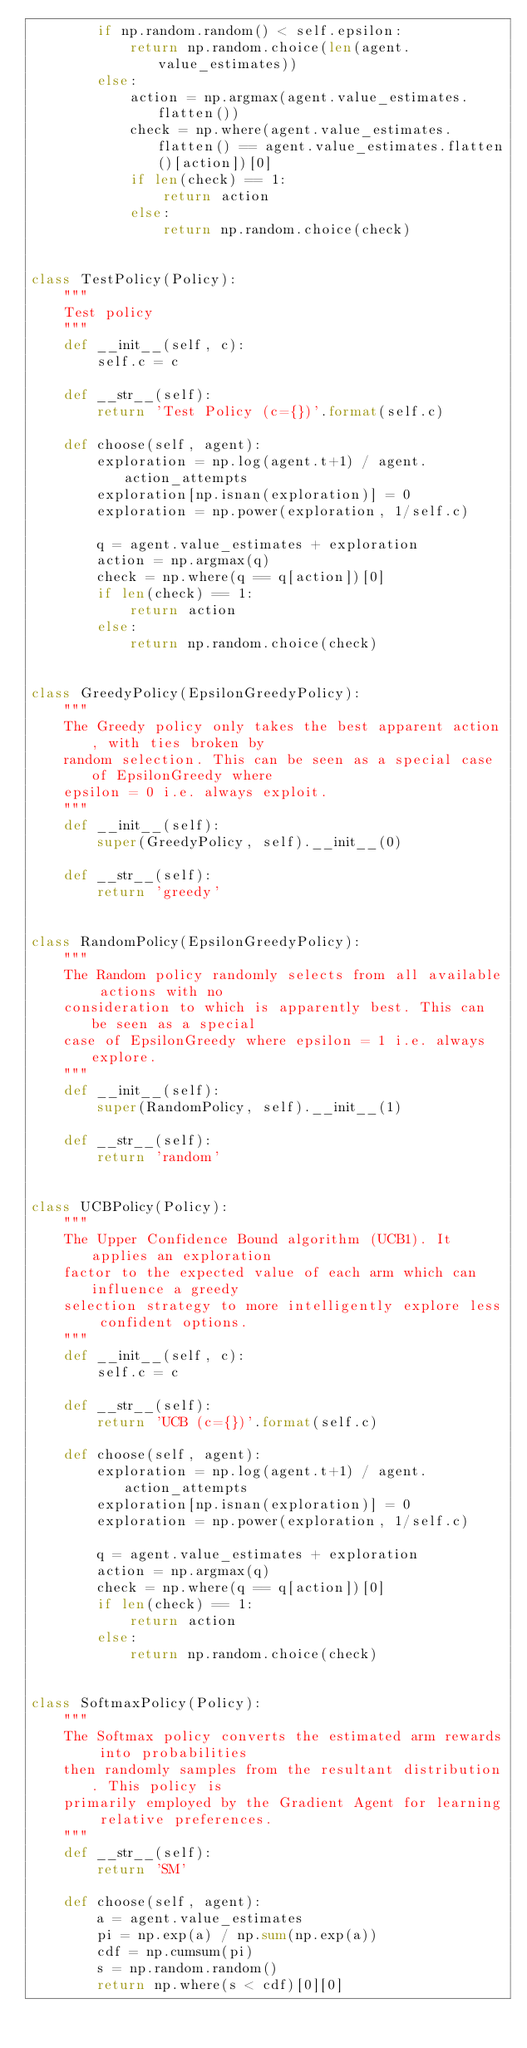<code> <loc_0><loc_0><loc_500><loc_500><_Python_>        if np.random.random() < self.epsilon:
            return np.random.choice(len(agent.value_estimates))
        else:
            action = np.argmax(agent.value_estimates.flatten())
            check = np.where(agent.value_estimates.flatten() == agent.value_estimates.flatten()[action])[0]
            if len(check) == 1:
                return action
            else:
                return np.random.choice(check)


class TestPolicy(Policy):
    """
    Test policy
    """
    def __init__(self, c):
        self.c = c

    def __str__(self):
        return 'Test Policy (c={})'.format(self.c)

    def choose(self, agent):
        exploration = np.log(agent.t+1) / agent.action_attempts
        exploration[np.isnan(exploration)] = 0
        exploration = np.power(exploration, 1/self.c)

        q = agent.value_estimates + exploration
        action = np.argmax(q)
        check = np.where(q == q[action])[0]
        if len(check) == 1:
            return action
        else:
            return np.random.choice(check)


class GreedyPolicy(EpsilonGreedyPolicy):
    """
    The Greedy policy only takes the best apparent action, with ties broken by
    random selection. This can be seen as a special case of EpsilonGreedy where
    epsilon = 0 i.e. always exploit.
    """
    def __init__(self):
        super(GreedyPolicy, self).__init__(0)

    def __str__(self):
        return 'greedy'


class RandomPolicy(EpsilonGreedyPolicy):
    """
    The Random policy randomly selects from all available actions with no
    consideration to which is apparently best. This can be seen as a special
    case of EpsilonGreedy where epsilon = 1 i.e. always explore.
    """
    def __init__(self):
        super(RandomPolicy, self).__init__(1)

    def __str__(self):
        return 'random'


class UCBPolicy(Policy):
    """
    The Upper Confidence Bound algorithm (UCB1). It applies an exploration
    factor to the expected value of each arm which can influence a greedy
    selection strategy to more intelligently explore less confident options.
    """
    def __init__(self, c):
        self.c = c

    def __str__(self):
        return 'UCB (c={})'.format(self.c)

    def choose(self, agent):
        exploration = np.log(agent.t+1) / agent.action_attempts
        exploration[np.isnan(exploration)] = 0
        exploration = np.power(exploration, 1/self.c)

        q = agent.value_estimates + exploration
        action = np.argmax(q)
        check = np.where(q == q[action])[0]
        if len(check) == 1:
            return action
        else:
            return np.random.choice(check)


class SoftmaxPolicy(Policy):
    """
    The Softmax policy converts the estimated arm rewards into probabilities
    then randomly samples from the resultant distribution. This policy is
    primarily employed by the Gradient Agent for learning relative preferences.
    """
    def __str__(self):
        return 'SM'

    def choose(self, agent):
        a = agent.value_estimates
        pi = np.exp(a) / np.sum(np.exp(a))
        cdf = np.cumsum(pi)
        s = np.random.random()
        return np.where(s < cdf)[0][0]
</code> 